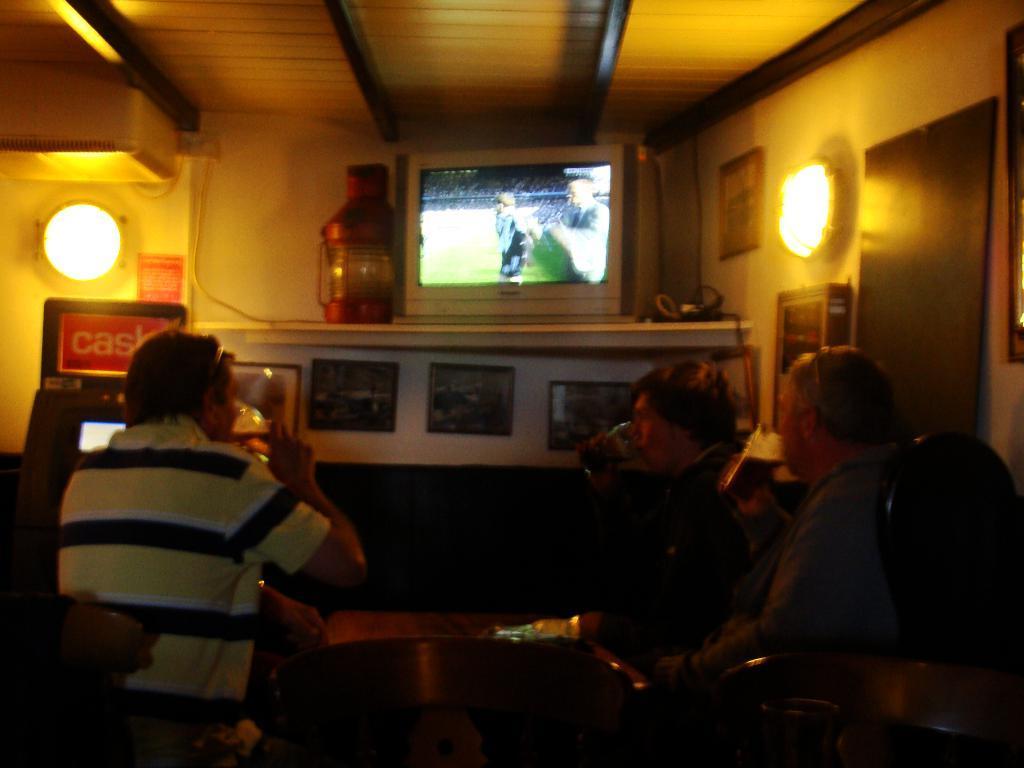Please provide a concise description of this image. There are people sitting and drinking as we can see at the bottom of this image. There is a television, lights, a wall and other objects are in the background. 